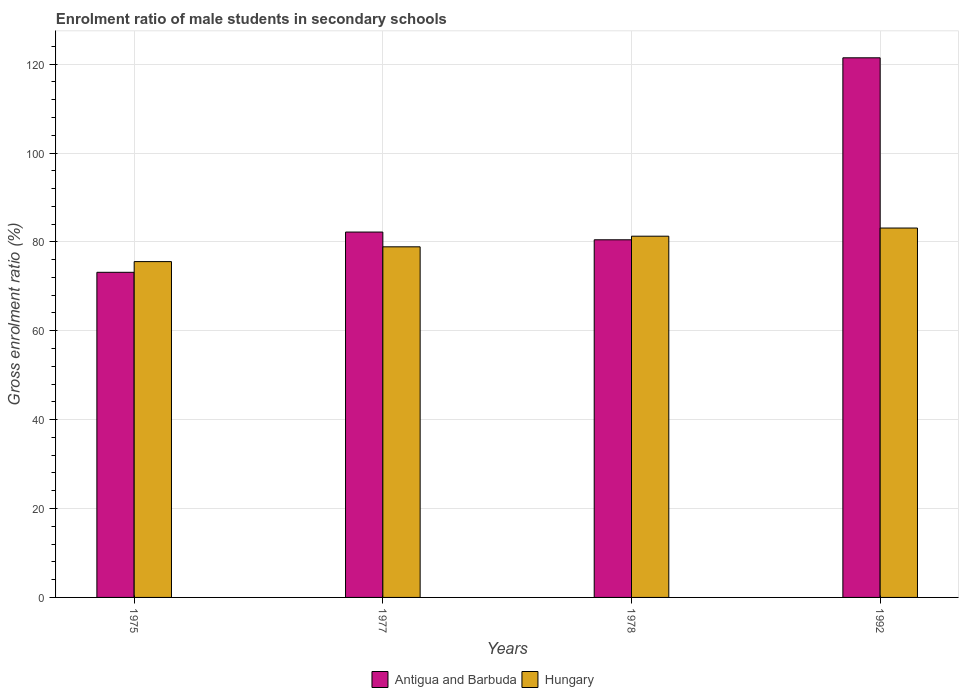Are the number of bars per tick equal to the number of legend labels?
Your answer should be compact. Yes. Are the number of bars on each tick of the X-axis equal?
Give a very brief answer. Yes. How many bars are there on the 2nd tick from the left?
Ensure brevity in your answer.  2. How many bars are there on the 2nd tick from the right?
Offer a terse response. 2. What is the enrolment ratio of male students in secondary schools in Antigua and Barbuda in 1978?
Your response must be concise. 80.47. Across all years, what is the maximum enrolment ratio of male students in secondary schools in Antigua and Barbuda?
Offer a very short reply. 121.42. Across all years, what is the minimum enrolment ratio of male students in secondary schools in Antigua and Barbuda?
Make the answer very short. 73.16. In which year was the enrolment ratio of male students in secondary schools in Antigua and Barbuda minimum?
Give a very brief answer. 1975. What is the total enrolment ratio of male students in secondary schools in Antigua and Barbuda in the graph?
Your answer should be compact. 357.26. What is the difference between the enrolment ratio of male students in secondary schools in Antigua and Barbuda in 1977 and that in 1978?
Offer a terse response. 1.74. What is the difference between the enrolment ratio of male students in secondary schools in Antigua and Barbuda in 1992 and the enrolment ratio of male students in secondary schools in Hungary in 1978?
Offer a terse response. 40.14. What is the average enrolment ratio of male students in secondary schools in Hungary per year?
Keep it short and to the point. 79.71. In the year 1978, what is the difference between the enrolment ratio of male students in secondary schools in Antigua and Barbuda and enrolment ratio of male students in secondary schools in Hungary?
Your answer should be very brief. -0.81. What is the ratio of the enrolment ratio of male students in secondary schools in Hungary in 1977 to that in 1978?
Keep it short and to the point. 0.97. Is the difference between the enrolment ratio of male students in secondary schools in Antigua and Barbuda in 1978 and 1992 greater than the difference between the enrolment ratio of male students in secondary schools in Hungary in 1978 and 1992?
Your answer should be compact. No. What is the difference between the highest and the second highest enrolment ratio of male students in secondary schools in Hungary?
Your answer should be very brief. 1.84. What is the difference between the highest and the lowest enrolment ratio of male students in secondary schools in Hungary?
Offer a terse response. 7.55. Is the sum of the enrolment ratio of male students in secondary schools in Antigua and Barbuda in 1975 and 1992 greater than the maximum enrolment ratio of male students in secondary schools in Hungary across all years?
Offer a very short reply. Yes. What does the 1st bar from the left in 1992 represents?
Make the answer very short. Antigua and Barbuda. What does the 2nd bar from the right in 1977 represents?
Your answer should be very brief. Antigua and Barbuda. How many years are there in the graph?
Offer a terse response. 4. What is the difference between two consecutive major ticks on the Y-axis?
Provide a succinct answer. 20. How are the legend labels stacked?
Keep it short and to the point. Horizontal. What is the title of the graph?
Offer a terse response. Enrolment ratio of male students in secondary schools. Does "Burundi" appear as one of the legend labels in the graph?
Offer a terse response. No. What is the label or title of the X-axis?
Your answer should be very brief. Years. What is the Gross enrolment ratio (%) of Antigua and Barbuda in 1975?
Keep it short and to the point. 73.16. What is the Gross enrolment ratio (%) in Hungary in 1975?
Ensure brevity in your answer.  75.56. What is the Gross enrolment ratio (%) of Antigua and Barbuda in 1977?
Keep it short and to the point. 82.21. What is the Gross enrolment ratio (%) in Hungary in 1977?
Your answer should be compact. 78.89. What is the Gross enrolment ratio (%) of Antigua and Barbuda in 1978?
Offer a terse response. 80.47. What is the Gross enrolment ratio (%) of Hungary in 1978?
Your answer should be very brief. 81.28. What is the Gross enrolment ratio (%) of Antigua and Barbuda in 1992?
Your answer should be very brief. 121.42. What is the Gross enrolment ratio (%) in Hungary in 1992?
Make the answer very short. 83.12. Across all years, what is the maximum Gross enrolment ratio (%) of Antigua and Barbuda?
Offer a very short reply. 121.42. Across all years, what is the maximum Gross enrolment ratio (%) of Hungary?
Ensure brevity in your answer.  83.12. Across all years, what is the minimum Gross enrolment ratio (%) in Antigua and Barbuda?
Your response must be concise. 73.16. Across all years, what is the minimum Gross enrolment ratio (%) in Hungary?
Offer a terse response. 75.56. What is the total Gross enrolment ratio (%) of Antigua and Barbuda in the graph?
Your answer should be very brief. 357.26. What is the total Gross enrolment ratio (%) of Hungary in the graph?
Give a very brief answer. 318.85. What is the difference between the Gross enrolment ratio (%) of Antigua and Barbuda in 1975 and that in 1977?
Make the answer very short. -9.06. What is the difference between the Gross enrolment ratio (%) in Hungary in 1975 and that in 1977?
Make the answer very short. -3.33. What is the difference between the Gross enrolment ratio (%) of Antigua and Barbuda in 1975 and that in 1978?
Offer a terse response. -7.32. What is the difference between the Gross enrolment ratio (%) of Hungary in 1975 and that in 1978?
Give a very brief answer. -5.72. What is the difference between the Gross enrolment ratio (%) of Antigua and Barbuda in 1975 and that in 1992?
Make the answer very short. -48.26. What is the difference between the Gross enrolment ratio (%) in Hungary in 1975 and that in 1992?
Give a very brief answer. -7.55. What is the difference between the Gross enrolment ratio (%) of Antigua and Barbuda in 1977 and that in 1978?
Ensure brevity in your answer.  1.74. What is the difference between the Gross enrolment ratio (%) in Hungary in 1977 and that in 1978?
Make the answer very short. -2.39. What is the difference between the Gross enrolment ratio (%) of Antigua and Barbuda in 1977 and that in 1992?
Provide a succinct answer. -39.21. What is the difference between the Gross enrolment ratio (%) of Hungary in 1977 and that in 1992?
Ensure brevity in your answer.  -4.22. What is the difference between the Gross enrolment ratio (%) of Antigua and Barbuda in 1978 and that in 1992?
Make the answer very short. -40.95. What is the difference between the Gross enrolment ratio (%) of Hungary in 1978 and that in 1992?
Give a very brief answer. -1.84. What is the difference between the Gross enrolment ratio (%) of Antigua and Barbuda in 1975 and the Gross enrolment ratio (%) of Hungary in 1977?
Your response must be concise. -5.74. What is the difference between the Gross enrolment ratio (%) of Antigua and Barbuda in 1975 and the Gross enrolment ratio (%) of Hungary in 1978?
Keep it short and to the point. -8.13. What is the difference between the Gross enrolment ratio (%) of Antigua and Barbuda in 1975 and the Gross enrolment ratio (%) of Hungary in 1992?
Give a very brief answer. -9.96. What is the difference between the Gross enrolment ratio (%) in Antigua and Barbuda in 1977 and the Gross enrolment ratio (%) in Hungary in 1978?
Make the answer very short. 0.93. What is the difference between the Gross enrolment ratio (%) of Antigua and Barbuda in 1977 and the Gross enrolment ratio (%) of Hungary in 1992?
Give a very brief answer. -0.9. What is the difference between the Gross enrolment ratio (%) in Antigua and Barbuda in 1978 and the Gross enrolment ratio (%) in Hungary in 1992?
Keep it short and to the point. -2.64. What is the average Gross enrolment ratio (%) of Antigua and Barbuda per year?
Offer a very short reply. 89.31. What is the average Gross enrolment ratio (%) of Hungary per year?
Your answer should be very brief. 79.71. In the year 1975, what is the difference between the Gross enrolment ratio (%) of Antigua and Barbuda and Gross enrolment ratio (%) of Hungary?
Your response must be concise. -2.41. In the year 1977, what is the difference between the Gross enrolment ratio (%) in Antigua and Barbuda and Gross enrolment ratio (%) in Hungary?
Give a very brief answer. 3.32. In the year 1978, what is the difference between the Gross enrolment ratio (%) in Antigua and Barbuda and Gross enrolment ratio (%) in Hungary?
Your answer should be compact. -0.81. In the year 1992, what is the difference between the Gross enrolment ratio (%) of Antigua and Barbuda and Gross enrolment ratio (%) of Hungary?
Keep it short and to the point. 38.3. What is the ratio of the Gross enrolment ratio (%) in Antigua and Barbuda in 1975 to that in 1977?
Ensure brevity in your answer.  0.89. What is the ratio of the Gross enrolment ratio (%) of Hungary in 1975 to that in 1977?
Keep it short and to the point. 0.96. What is the ratio of the Gross enrolment ratio (%) in Antigua and Barbuda in 1975 to that in 1978?
Your answer should be compact. 0.91. What is the ratio of the Gross enrolment ratio (%) of Hungary in 1975 to that in 1978?
Ensure brevity in your answer.  0.93. What is the ratio of the Gross enrolment ratio (%) in Antigua and Barbuda in 1975 to that in 1992?
Ensure brevity in your answer.  0.6. What is the ratio of the Gross enrolment ratio (%) in Antigua and Barbuda in 1977 to that in 1978?
Provide a succinct answer. 1.02. What is the ratio of the Gross enrolment ratio (%) of Hungary in 1977 to that in 1978?
Ensure brevity in your answer.  0.97. What is the ratio of the Gross enrolment ratio (%) of Antigua and Barbuda in 1977 to that in 1992?
Offer a very short reply. 0.68. What is the ratio of the Gross enrolment ratio (%) of Hungary in 1977 to that in 1992?
Offer a terse response. 0.95. What is the ratio of the Gross enrolment ratio (%) in Antigua and Barbuda in 1978 to that in 1992?
Offer a terse response. 0.66. What is the ratio of the Gross enrolment ratio (%) in Hungary in 1978 to that in 1992?
Provide a succinct answer. 0.98. What is the difference between the highest and the second highest Gross enrolment ratio (%) in Antigua and Barbuda?
Your answer should be very brief. 39.21. What is the difference between the highest and the second highest Gross enrolment ratio (%) in Hungary?
Provide a short and direct response. 1.84. What is the difference between the highest and the lowest Gross enrolment ratio (%) of Antigua and Barbuda?
Keep it short and to the point. 48.26. What is the difference between the highest and the lowest Gross enrolment ratio (%) of Hungary?
Your response must be concise. 7.55. 